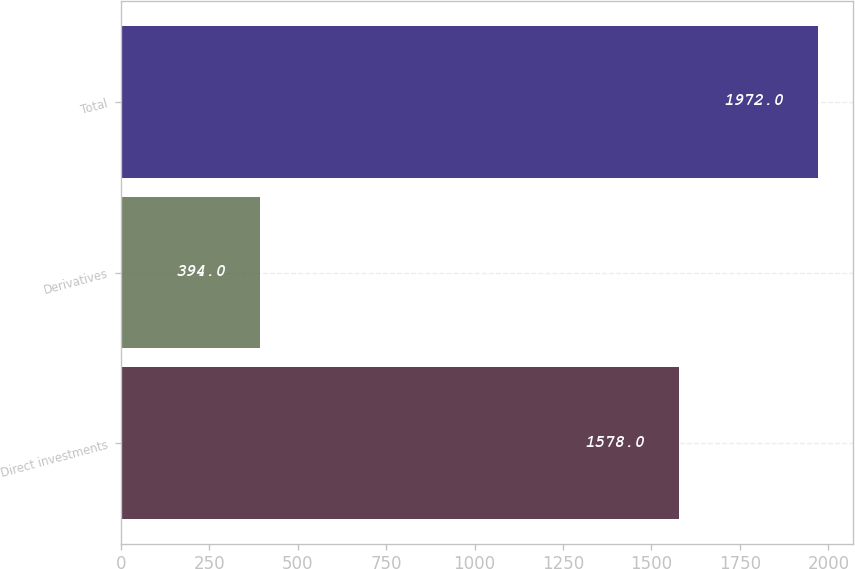<chart> <loc_0><loc_0><loc_500><loc_500><bar_chart><fcel>Direct investments<fcel>Derivatives<fcel>Total<nl><fcel>1578<fcel>394<fcel>1972<nl></chart> 